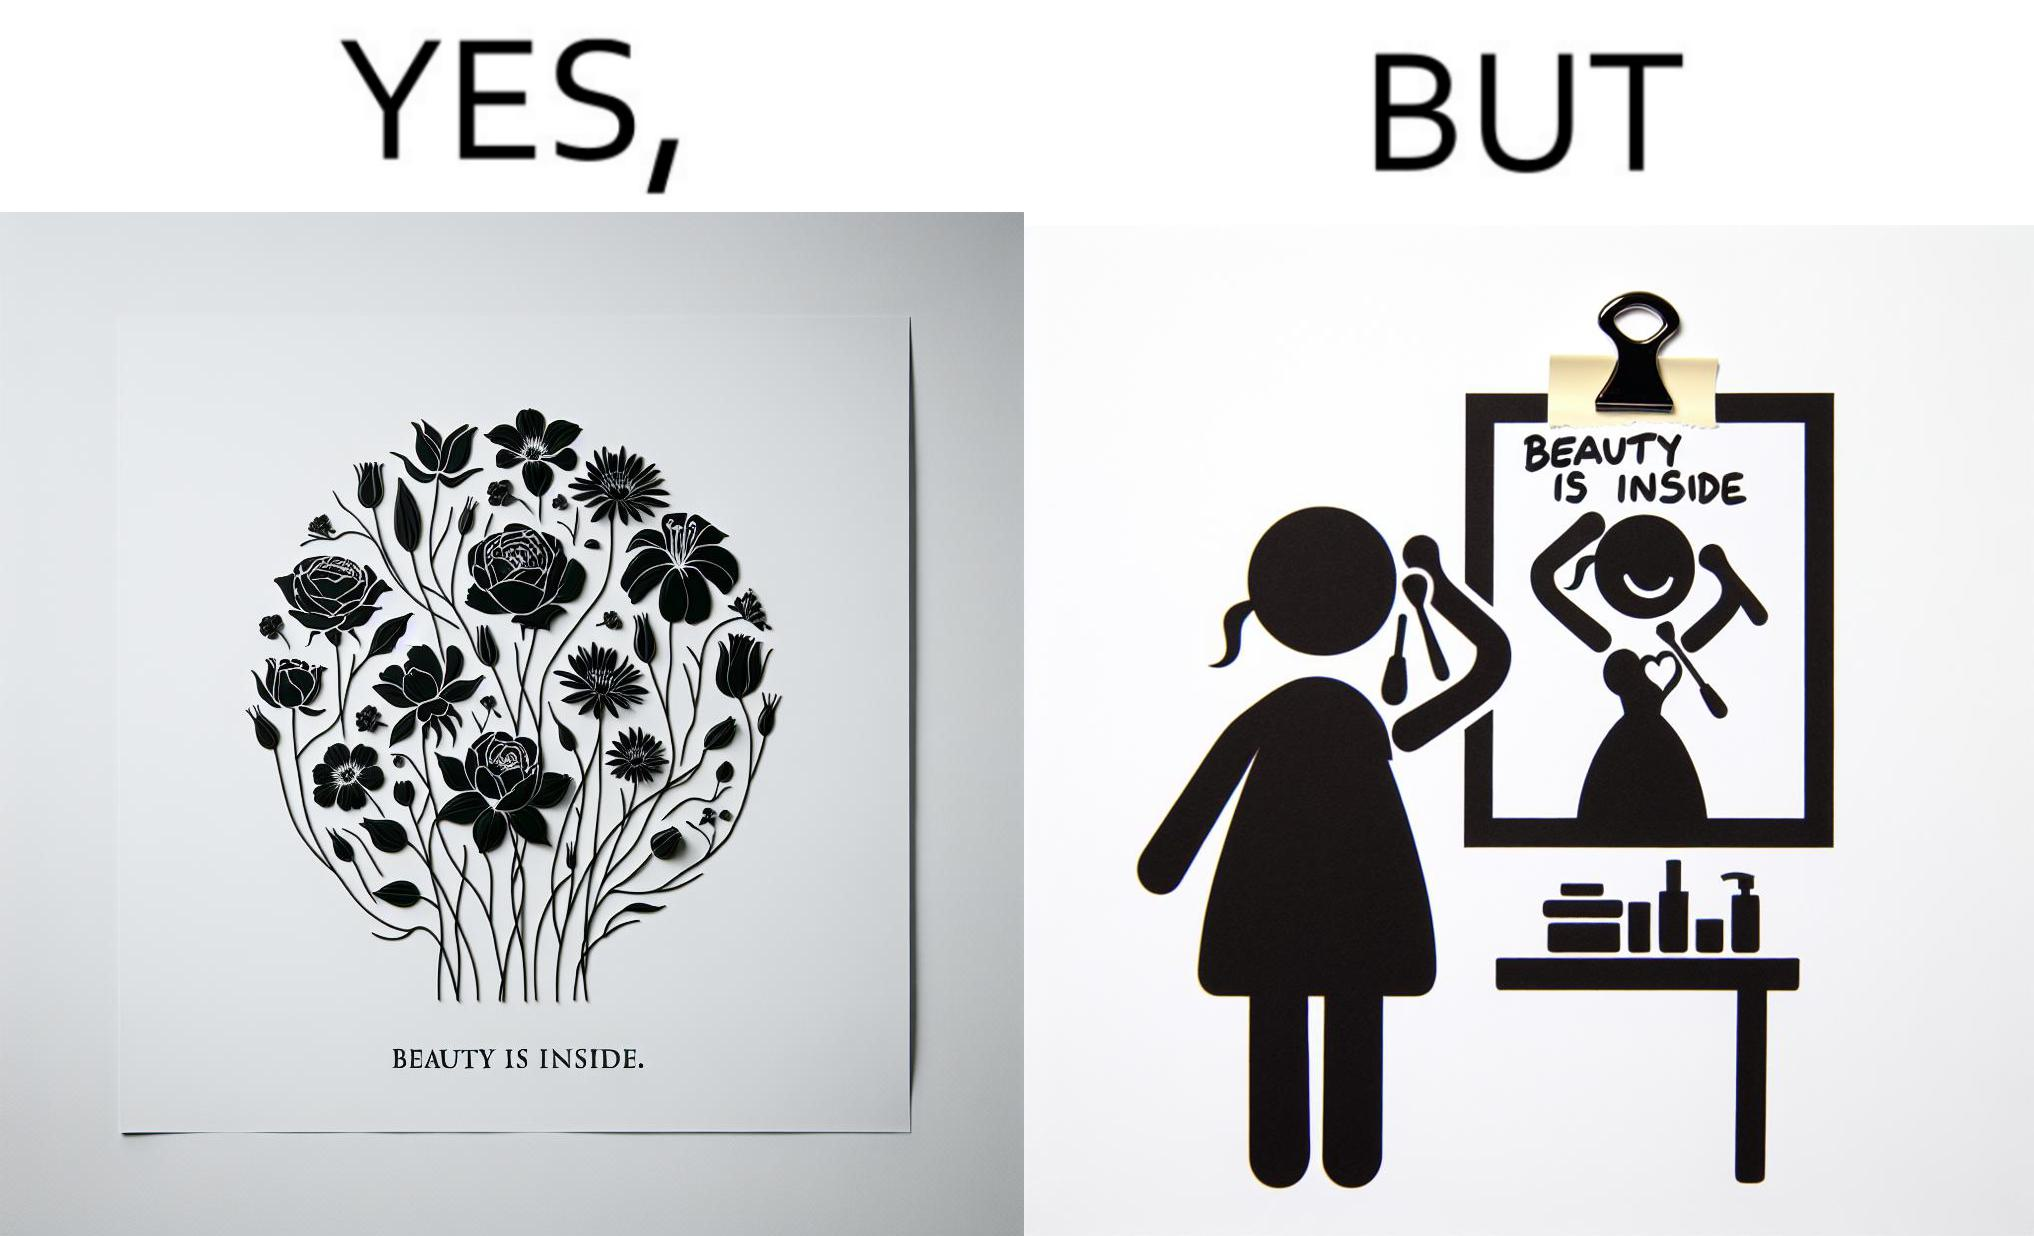Describe the satirical element in this image. The image is satirical because while the text on the paper says that beauty lies inside, the woman ignores the note and continues to apply makeup to improve her outer beauty. 